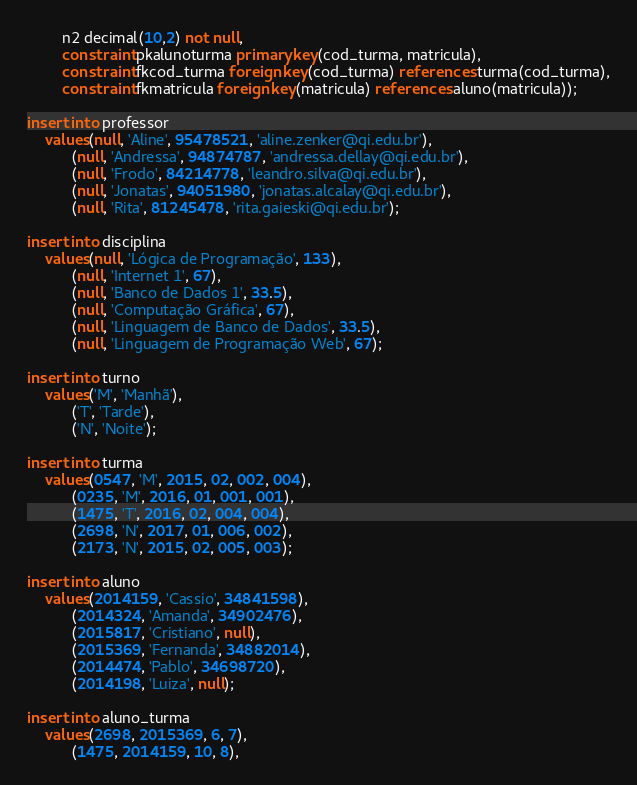Convert code to text. <code><loc_0><loc_0><loc_500><loc_500><_SQL_>        n2 decimal(10,2) not null,
        constraint pkalunoturma primary key(cod_turma, matricula),
        constraint fkcod_turma foreign key(cod_turma) references turma(cod_turma),
        constraint fkmatricula foreign key(matricula) references aluno(matricula));
        
insert into professor
	values(null, 'Aline', 95478521, 'aline.zenker@qi.edu.br'),
		  (null, 'Andressa', 94874787, 'andressa.dellay@qi.edu.br'),
          (null, 'Frodo', 84214778, 'leandro.silva@qi.edu.br'),
          (null, 'Jonatas', 94051980, 'jonatas.alcalay@qi.edu.br'),
          (null, 'Rita', 81245478, 'rita.gaieski@qi.edu.br');
          
insert into disciplina
	values(null, 'Lógica de Programação', 133),
		  (null, 'Internet 1', 67),
          (null, 'Banco de Dados 1', 33.5),
          (null, 'Computação Gráfica', 67),
          (null, 'Linguagem de Banco de Dados', 33.5),
          (null, 'Linguagem de Programação Web', 67);
          
insert into turno
	values('M', 'Manhã'),
		  ('T', 'Tarde'),
          ('N', 'Noite');

insert into turma
	values(0547, 'M', 2015, 02, 002, 004),
		  (0235, 'M', 2016, 01, 001, 001),
          (1475, 'T', 2016, 02, 004, 004),
		  (2698, 'N', 2017, 01, 006, 002),
          (2173, 'N', 2015, 02, 005, 003);
         
insert into aluno
	values(2014159, 'Cassio', 34841598),
		  (2014324, 'Amanda', 34902476),
          (2015817, 'Cristiano', null),
          (2015369, 'Fernanda', 34882014),
          (2014474, 'Pablo', 34698720),
          (2014198, 'Luiza', null);
          
insert into aluno_turma
	values(2698, 2015369, 6, 7),
		  (1475, 2014159, 10, 8),</code> 